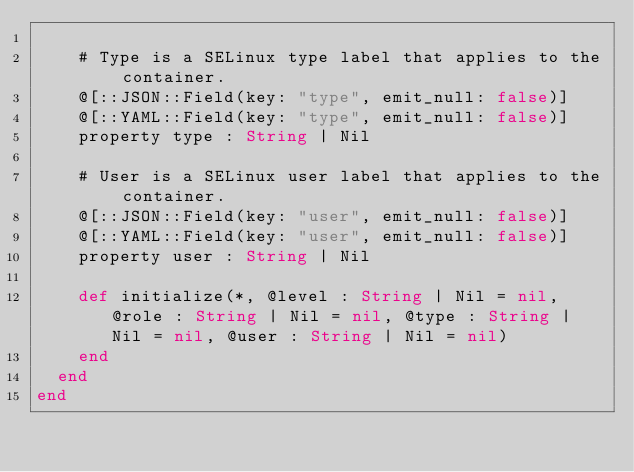<code> <loc_0><loc_0><loc_500><loc_500><_Crystal_>
    # Type is a SELinux type label that applies to the container.
    @[::JSON::Field(key: "type", emit_null: false)]
    @[::YAML::Field(key: "type", emit_null: false)]
    property type : String | Nil

    # User is a SELinux user label that applies to the container.
    @[::JSON::Field(key: "user", emit_null: false)]
    @[::YAML::Field(key: "user", emit_null: false)]
    property user : String | Nil

    def initialize(*, @level : String | Nil = nil, @role : String | Nil = nil, @type : String | Nil = nil, @user : String | Nil = nil)
    end
  end
end
</code> 